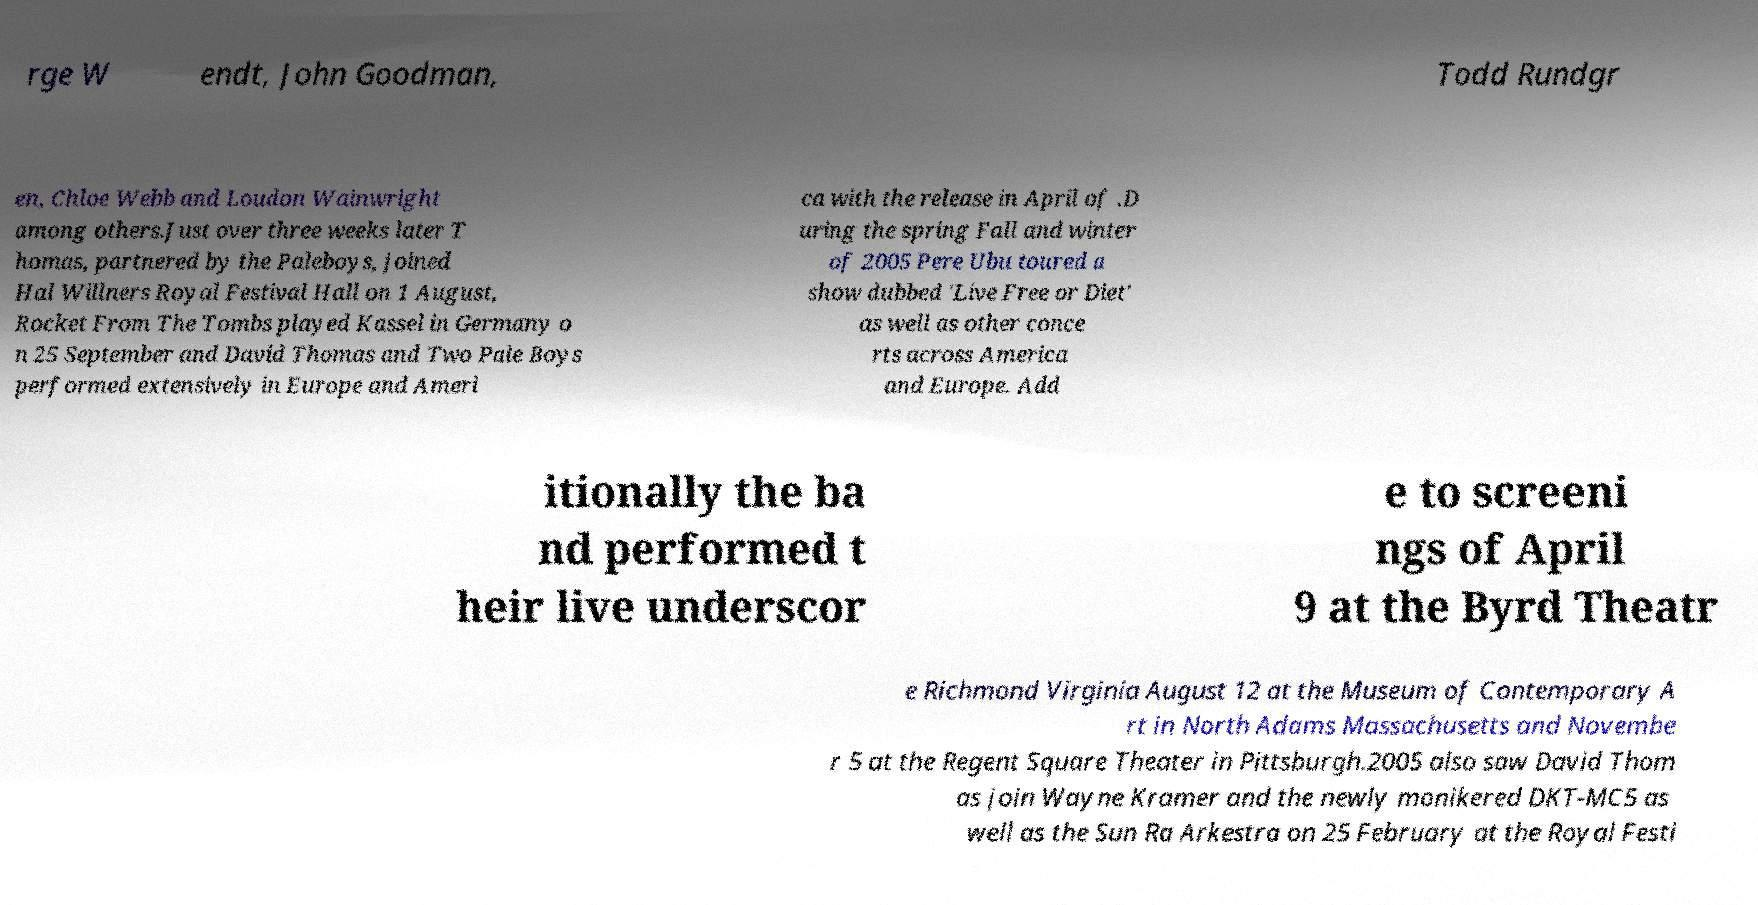Please read and relay the text visible in this image. What does it say? rge W endt, John Goodman, Todd Rundgr en, Chloe Webb and Loudon Wainwright among others.Just over three weeks later T homas, partnered by the Paleboys, joined Hal Willners Royal Festival Hall on 1 August, Rocket From The Tombs played Kassel in Germany o n 25 September and David Thomas and Two Pale Boys performed extensively in Europe and Ameri ca with the release in April of .D uring the spring Fall and winter of 2005 Pere Ubu toured a show dubbed 'Live Free or Diet' as well as other conce rts across America and Europe. Add itionally the ba nd performed t heir live underscor e to screeni ngs of April 9 at the Byrd Theatr e Richmond Virginia August 12 at the Museum of Contemporary A rt in North Adams Massachusetts and Novembe r 5 at the Regent Square Theater in Pittsburgh.2005 also saw David Thom as join Wayne Kramer and the newly monikered DKT-MC5 as well as the Sun Ra Arkestra on 25 February at the Royal Festi 